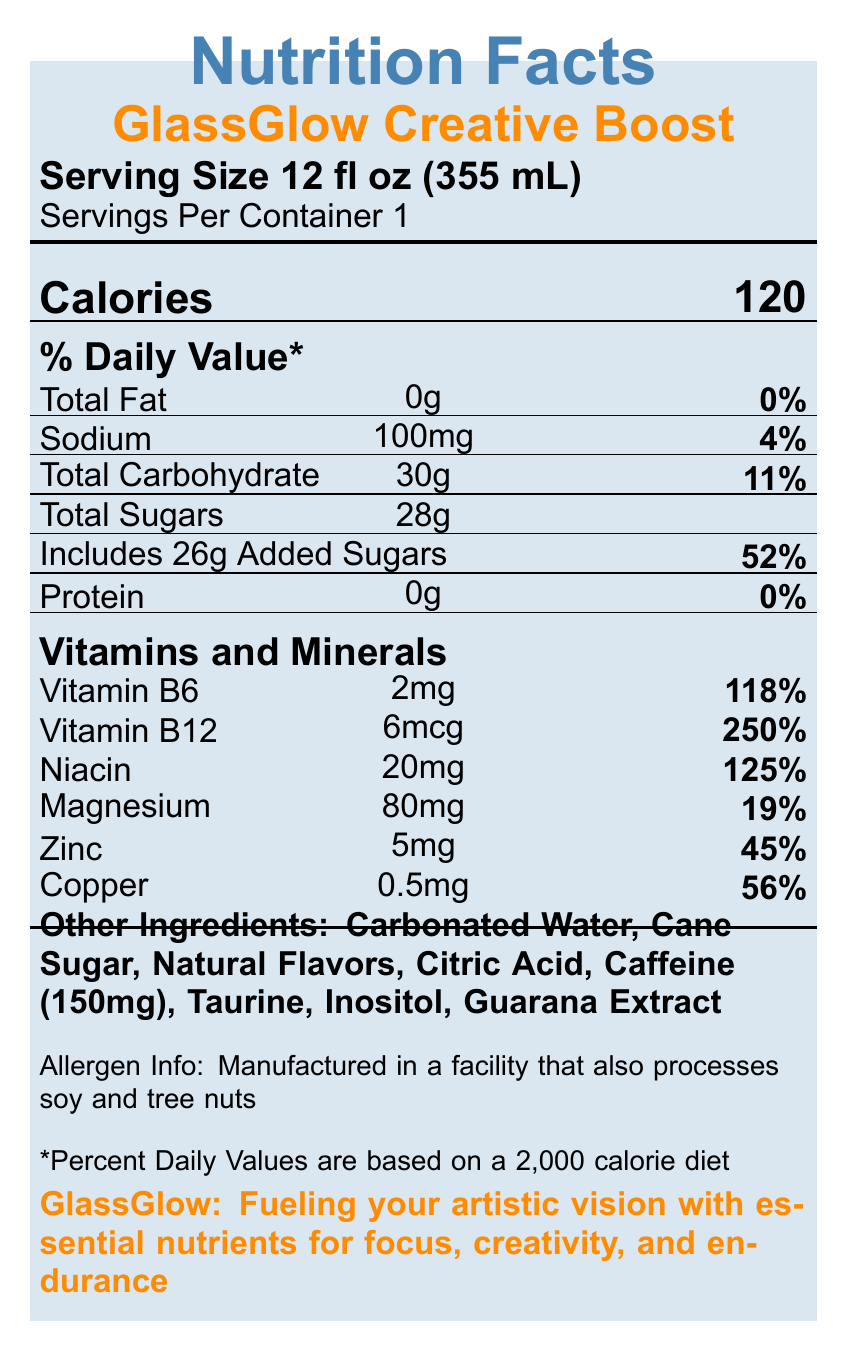How many calories are in one serving of GlassGlow Creative Boost? The document states "Calories" and mentions "120" next to it, indicating the amount per serving.
Answer: 120 calories What is the serving size of GlassGlow Creative Boost? The document states "Serving Size 12 fl oz (355 mL)" at the top of the label.
Answer: 12 fl oz (355 mL) What percentage of the daily value of Vitamin B6 does a serving of GlassGlow Creative Boost provide? The document lists "Vitamin B6" with an amount of "2mg" and a daily value of "118%".
Answer: 118% List the vitamins and minerals included in GlassGlow Creative Boost. The section "Vitamins and Minerals" lists each of these with their corresponding amounts and daily values.
Answer: Vitamin B6, Vitamin B12, Niacin, Magnesium, Zinc, Copper Is there any fat in GlassGlow Creative Boost? The document indicates "Total Fat 0g 0%" under the nutrient table, suggesting no fat content.
Answer: No How much caffeine is in one serving of GlassGlow Creative Boost? A. 50mg B. 100mg C. 150mg D. 200mg Under "Other Ingredients," the document lists "Caffeine (150mg)".
Answer: C. 150mg What is the first ingredient listed under "Other Ingredients"? A. Cane Sugar B. Natural Flavors C. Carbonated Water D. Citric Acid The document lists ingredients starting with "Carbonated Water".
Answer: C. Carbonated Water Does this beverage contain any protein? The document lists "Protein 0g 0%" in the nutrient table.
Answer: No Does GlassGlow Creative Boost contain any common allergens? The document states, "Manufactured in a facility that also processes soy and tree nuts" under allergen info.
Answer: Yes Summarize the key features and nutritional values of GlassGlow Creative Boost. The summary collects and describes all the main nutritional information and ingredients included in the document, along with the brand's statement.
Answer: GlassGlow Creative Boost is a 12 fl oz (355 mL) energy drink with 120 calories per serving. It contains high levels of vitamins and minerals such as Vitamin B6 (118%), Vitamin B12 (250%), Niacin (125%), Magnesium (19%), Zinc (45%), and Copper (56%). It has 0g of fat and protein, 100mg of sodium, 30g of carbohydrates (including 28g of total sugars and 26g of added sugars). The drink also contains 150mg of caffeine along with taurine, inositol, and guarana extract. It is made in a facility that processes soy and tree nuts and claims to support focus, creativity, and endurance. What is the main purpose of GlassGlow Creative Boost according to the brand statement? The document includes a "Brand Statement" that claims the drink's purpose is "Fueling your artistic vision with essential nutrients for focus, creativity, and endurance."
Answer: To fuel artistic vision with essential nutrients for focus, creativity, and endurance Which vitamin has the highest percentage of daily value in GlassGlow Creative Boost? A. Vitamin B6 B. Vitamin B12 C. Niacin D. Magnesium The document lists Vitamin B12 with a daily value percentage of 250%, the highest among the listed vitamins and minerals.
Answer: B. Vitamin B12 How much sodium does one serving of GlassGlow Creative Boost contain? The document states "Sodium 100mg 4%" under the nutrient table.
Answer: 100mg How many grams of added sugars are present in one serving? The document states "Includes 26g Added Sugars 52%" under "Total Sugars."
Answer: 26g What is the percentage daily value of copper in one serving of GlassGlow Creative Boost? The document lists "Copper 0.5mg 56%" under "Vitamins and Minerals."
Answer: 56% Which of the following is NOT an ingredient in GlassGlow Creative Boost? A. Magnesium B. Carbonated Water C. Inositol D. Guarana Extract Magnesium is listed under "Vitamins and Minerals" but is not an "Other Ingredients."
Answer: A. Magnesium What is the source of caffeine in GlassGlow Creative Boost? The document lists "Caffeine (150mg)" under "Other Ingredients," but it does not specify its source.
Answer: The source is not specified Are the nutrient percentages based on a specific diet? The document states "*Percent Daily Values are based on a 2,000 calorie diet."
Answer: Yes Does the drink contain any taurine? The document lists "Taurine" under "Other Ingredients."
Answer: Yes Is there any information on whether the drink contains gluten? The document does not provide any information about gluten content.
Answer: No What is the total carbohydrate content per serving? The document lists "Total Carbohydrate 30g 11%" under the nutrient table.
Answer: 30g 